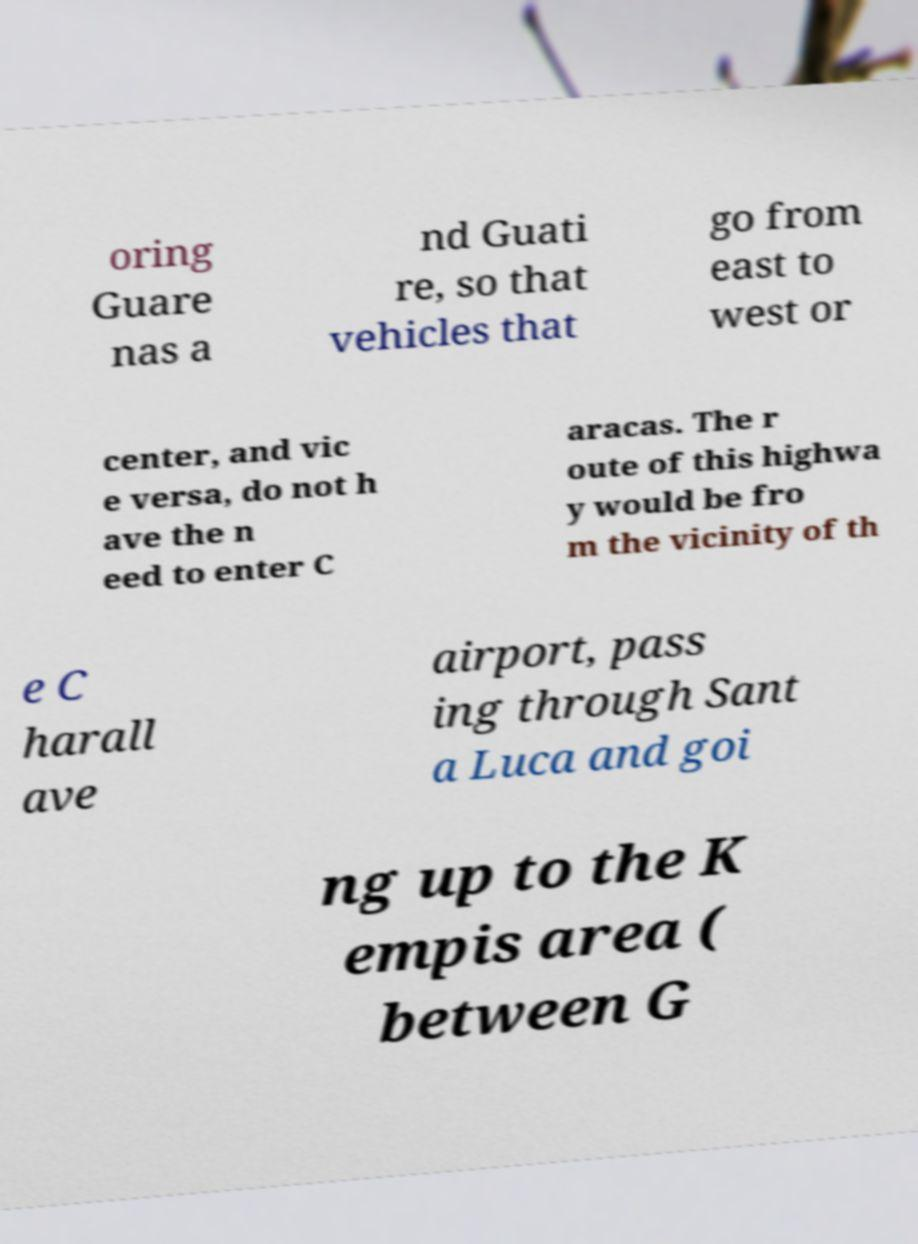For documentation purposes, I need the text within this image transcribed. Could you provide that? oring Guare nas a nd Guati re, so that vehicles that go from east to west or center, and vic e versa, do not h ave the n eed to enter C aracas. The r oute of this highwa y would be fro m the vicinity of th e C harall ave airport, pass ing through Sant a Luca and goi ng up to the K empis area ( between G 